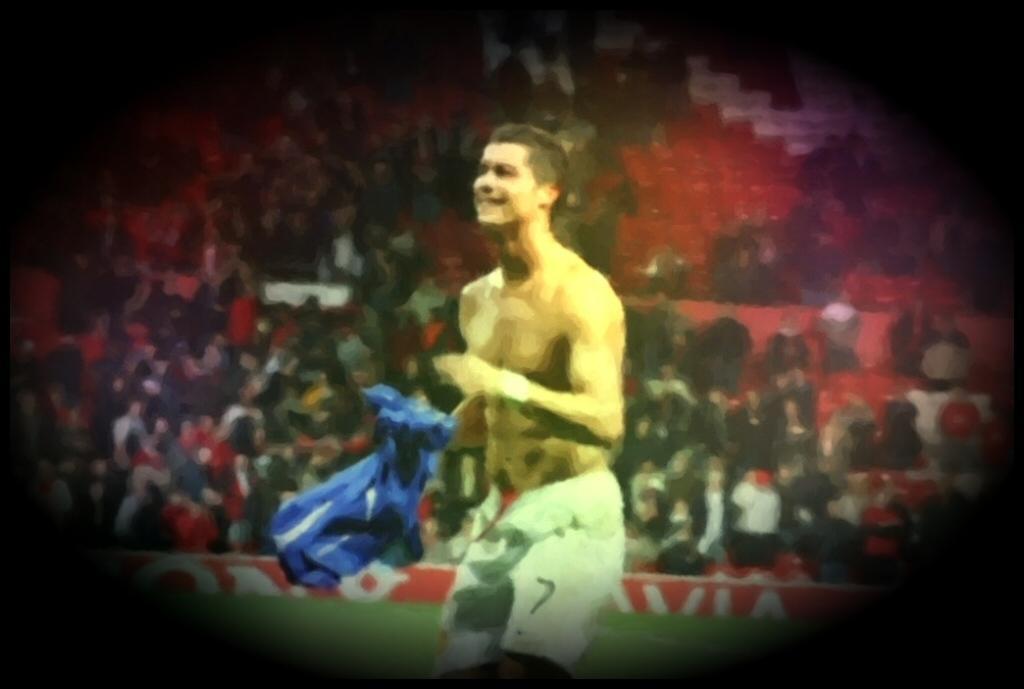How would you summarize this image in a sentence or two? In the image we can see a man standing, wearing shorts and he is smiling. Here we can see the audience, grass and the corners of the image are dark. 